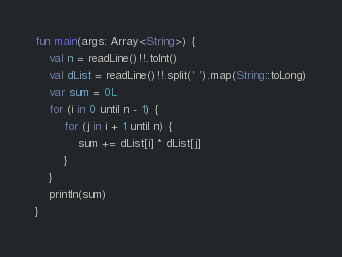<code> <loc_0><loc_0><loc_500><loc_500><_Kotlin_>fun main(args: Array<String>) {
    val n = readLine()!!.toInt()
    val dList = readLine()!!.split(' ').map(String::toLong)
    var sum = 0L
    for (i in 0 until n - 1) {
        for (j in i + 1 until n) {
            sum += dList[i] * dList[j]
        }
    }
    println(sum)
}</code> 